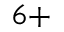Convert formula to latex. <formula><loc_0><loc_0><loc_500><loc_500>^ { 6 + }</formula> 